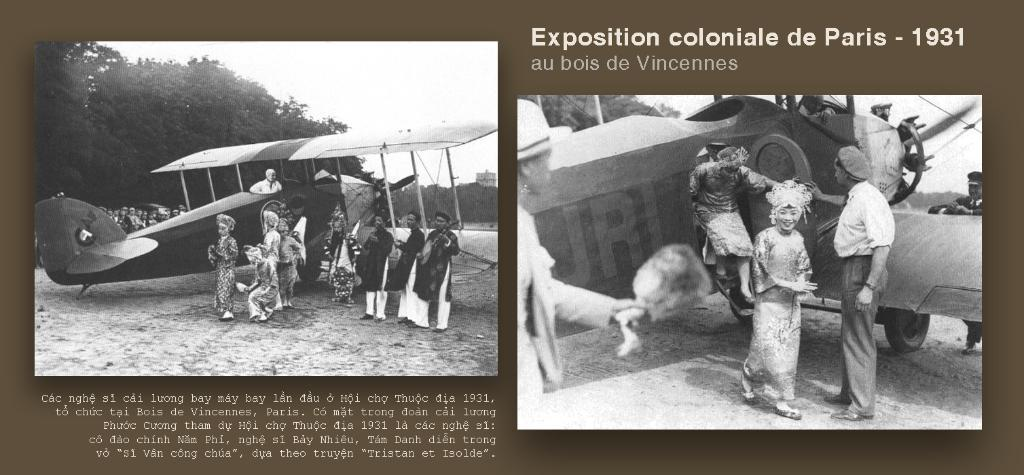What is the color scheme of the image? The image is black and white. What can be seen on the ground in the image? There are persons on the ground in the image. What is the main object in the sky in the image? There is an airplane in the image. What type of natural environment is visible in the background of the image? There are trees in the background of the image, and the sky is visible as well. What type of magic is being performed by the persons on the ground in the image? There is no indication of magic or any magical activity in the image; it simply shows persons on the ground. How many things can be counted in the image? The question of counting "things" is vague and cannot be definitively answered based on the provided facts. The image contains an airplane, trees, persons, and a sky, but it is unclear what else might be considered a "thing" in this context. 